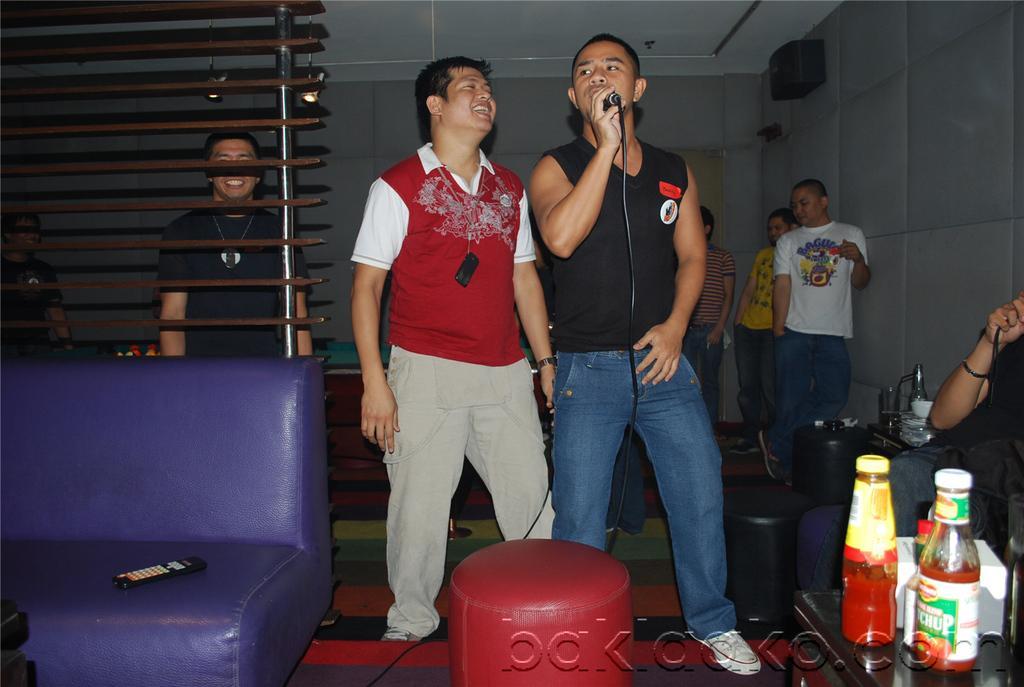Can you describe this image briefly? In this image I can see people where one is sitting and rest all are standing. I can see smile on few faces and here I can see one of them is holding a mic. I can also see a purple colour sofa and on it I can see a remote. I can also see few bottles and a box over here. 